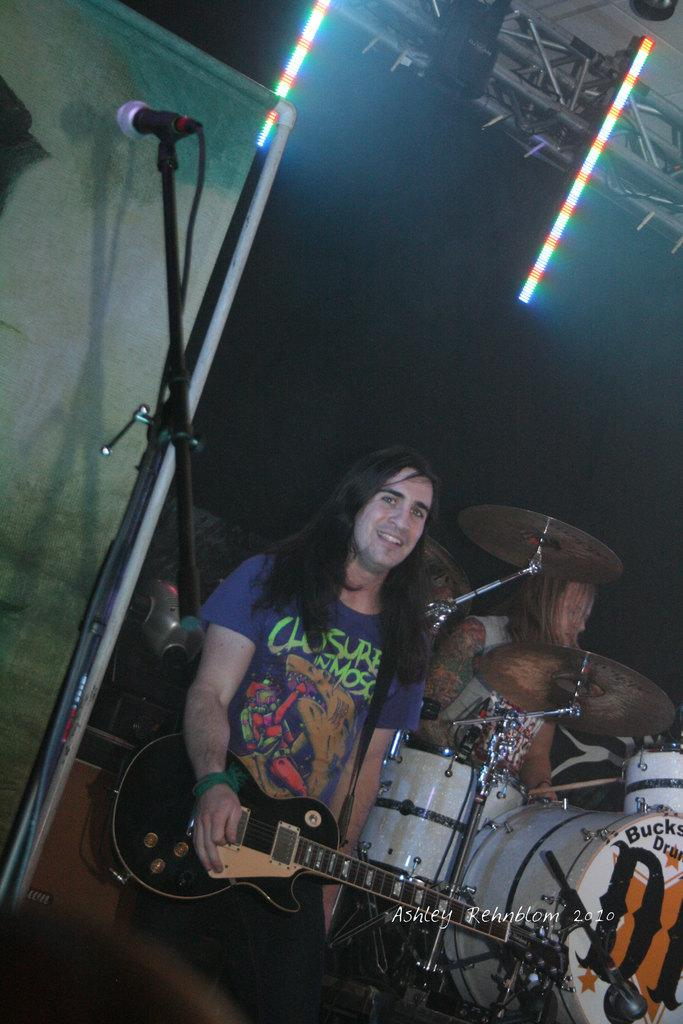What is the man in the image doing? The man is playing a guitar. What object is the man positioned in front of? The man is in front of a microphone. What expression does the man have on his face? The man is smiling. How many centimeters is the cloud visible in the image? There is no cloud present in the image. What type of guide is the man holding in the image? There is no guide present in the image; the man is playing a guitar and standing in front of a microphone. 